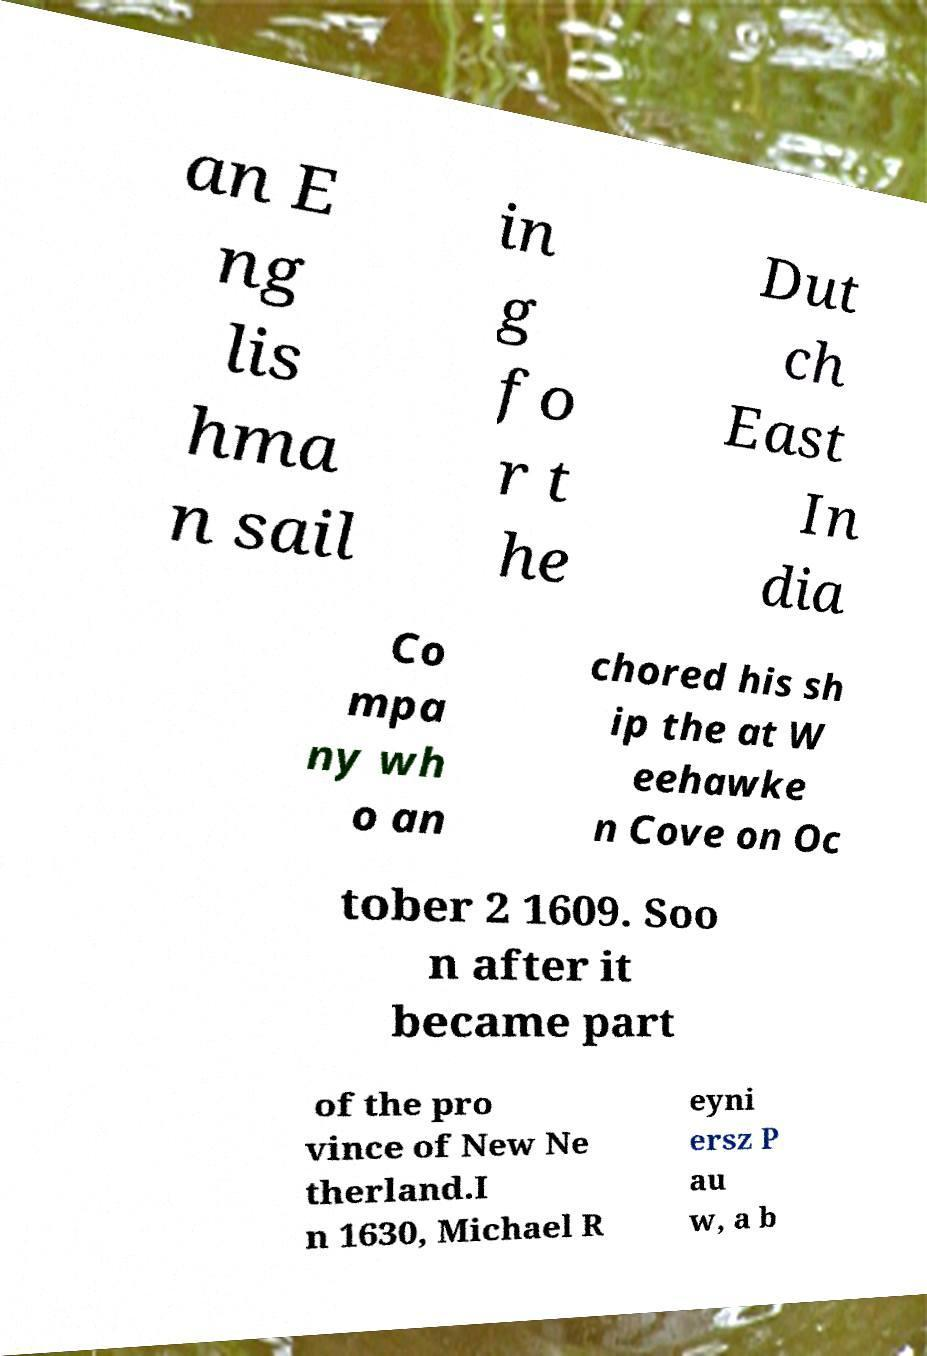Please identify and transcribe the text found in this image. an E ng lis hma n sail in g fo r t he Dut ch East In dia Co mpa ny wh o an chored his sh ip the at W eehawke n Cove on Oc tober 2 1609. Soo n after it became part of the pro vince of New Ne therland.I n 1630, Michael R eyni ersz P au w, a b 